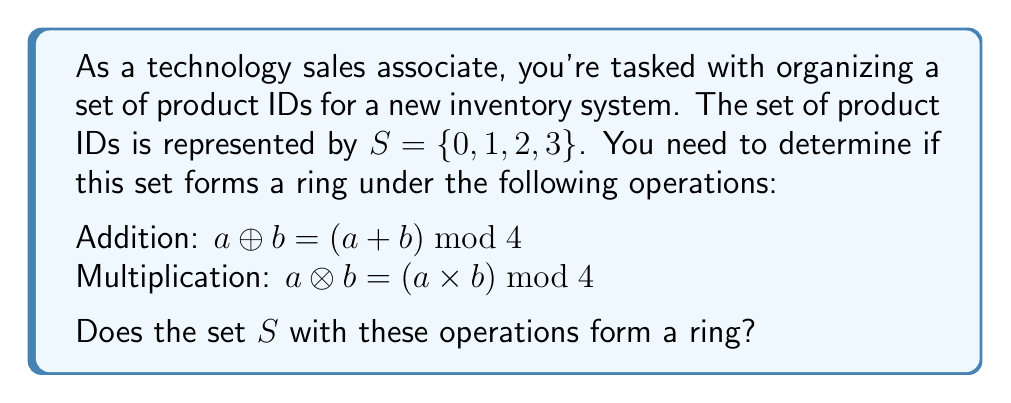Teach me how to tackle this problem. To determine if the set $S = \{0, 1, 2, 3\}$ forms a ring under the given operations, we need to check if it satisfies all the ring axioms:

1. $(S, \oplus)$ is an abelian group:
   a. Closure: For all $a, b \in S$, $a \oplus b \in S$. This is true because $(a + b) \bmod 4$ always results in an element of $S$.
   b. Associativity: $(a \oplus b) \oplus c = a \oplus (b \oplus c)$ for all $a, b, c \in S$. This holds due to the properties of modular arithmetic.
   c. Commutativity: $a \oplus b = b \oplus a$ for all $a, b \in S$. This is true because addition is commutative.
   d. Identity element: $0 \oplus a = a \oplus 0 = a$ for all $a \in S$. The identity element is 0.
   e. Inverse elements: For each $a \in S$, there exists $-a \in S$ such that $a \oplus (-a) = 0$. The inverses are: $0 \rightarrow 0$, $1 \rightarrow 3$, $2 \rightarrow 2$, $3 \rightarrow 1$.

2. $(S, \otimes)$ is a monoid:
   a. Closure: For all $a, b \in S$, $a \otimes b \in S$. This is true because $(a \times b) \bmod 4$ always results in an element of $S$.
   b. Associativity: $(a \otimes b) \otimes c = a \otimes (b \otimes c)$ for all $a, b, c \in S$. This holds due to the properties of modular arithmetic.
   c. Identity element: $1 \otimes a = a \otimes 1 = a$ for all $a \in S$. The identity element is 1.

3. Distributivity:
   a. Left distributivity: $a \otimes (b \oplus c) = (a \otimes b) \oplus (a \otimes c)$ for all $a, b, c \in S$.
   b. Right distributivity: $(a \oplus b) \otimes c = (a \otimes c) \oplus (b \otimes c)$ for all $a, b, c \in S$.

All these properties hold for the given set and operations. Therefore, $(S, \oplus, \otimes)$ forms a ring.
Answer: Yes, $S$ forms a ring under the given operations. 